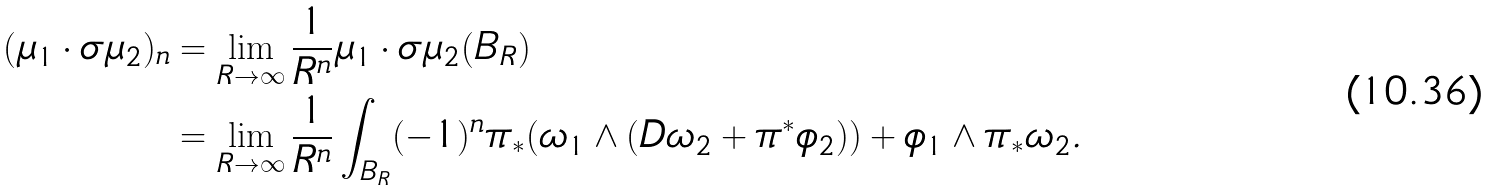Convert formula to latex. <formula><loc_0><loc_0><loc_500><loc_500>( \mu _ { 1 } \cdot \sigma \mu _ { 2 } ) _ { n } & = \lim _ { R \to \infty } \frac { 1 } { R ^ { n } } \mu _ { 1 } \cdot \sigma \mu _ { 2 } ( B _ { R } ) \\ & = \lim _ { R \to \infty } \frac { 1 } { R ^ { n } } \int _ { B _ { R } } ( - 1 ) ^ { n } \pi _ { * } ( \omega _ { 1 } \wedge ( D \omega _ { 2 } + \pi ^ { * } \phi _ { 2 } ) ) + \phi _ { 1 } \wedge \pi _ { * } \omega _ { 2 } .</formula> 